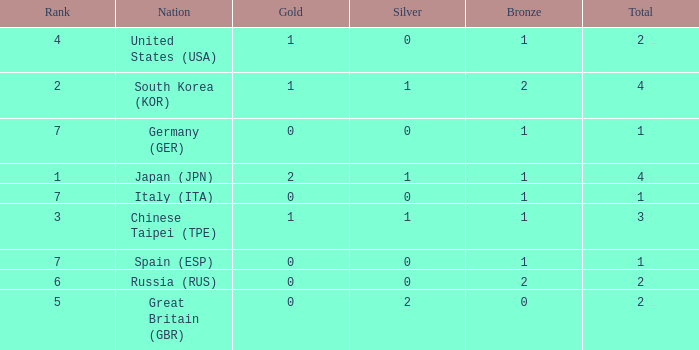What is the rank of the country with more than 2 medals, and 2 gold medals? 1.0. 